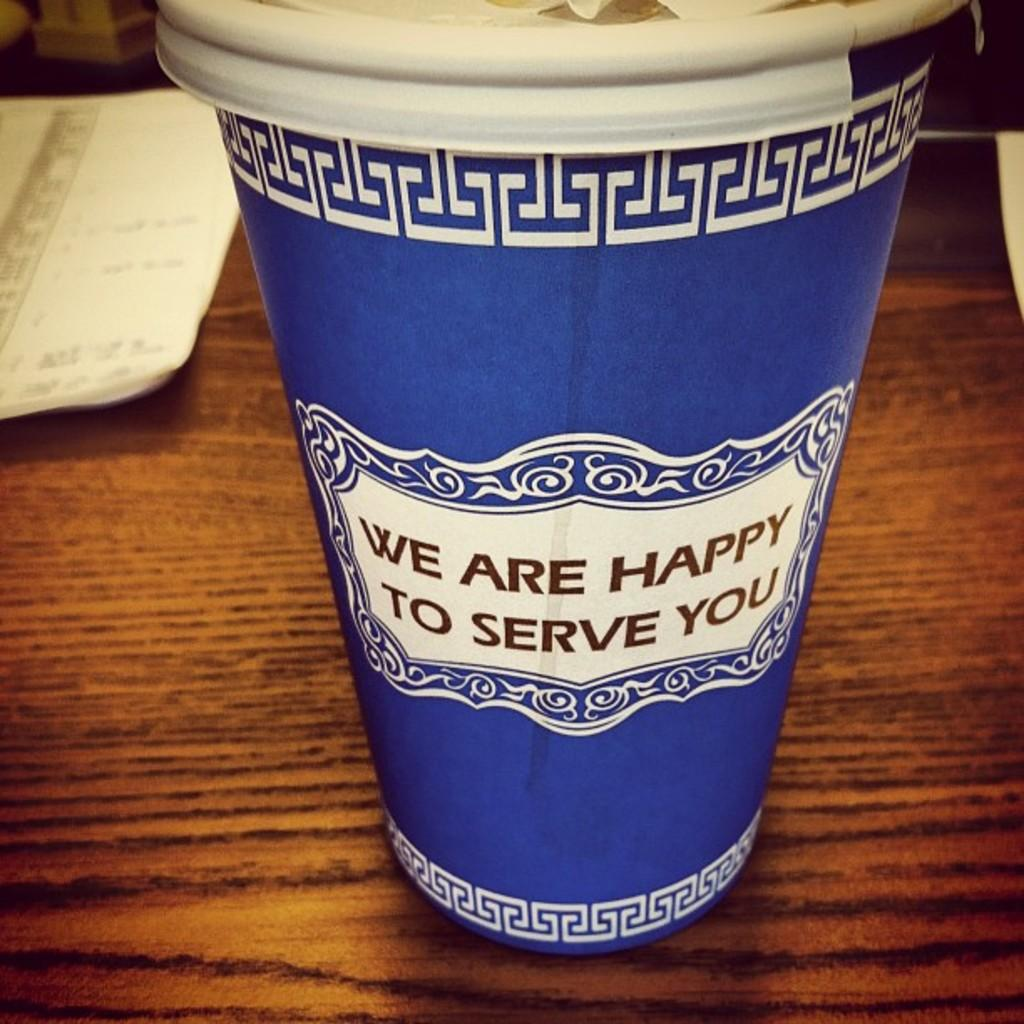What is present in the image that can hold liquids? There is a cup in the image that can hold liquids. What type of items can be seen in the image that are typically used for writing or reading? There are papers in the image that are typically used for writing or reading. What is the color of the surface the cup and papers are resting on? The surface the cup and papers are on is brown in color. How many legs can be seen supporting the cup in the image? There are no legs visible in the image; the cup is resting on a surface. What type of screw is used to fasten the papers to the cup in the image? There are no screws present in the image; the papers are simply placed on the surface next to the cup. 